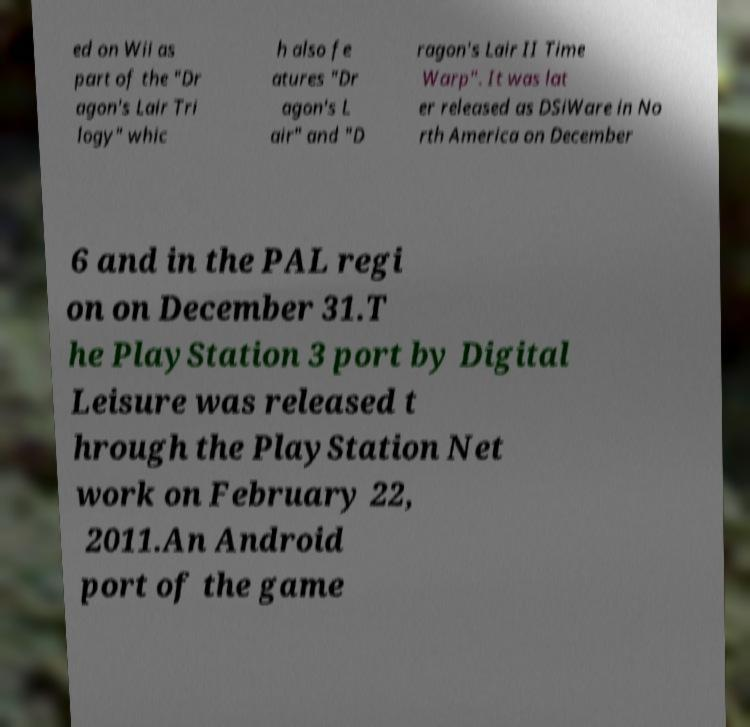What messages or text are displayed in this image? I need them in a readable, typed format. ed on Wii as part of the "Dr agon's Lair Tri logy" whic h also fe atures "Dr agon's L air" and "D ragon's Lair II Time Warp". It was lat er released as DSiWare in No rth America on December 6 and in the PAL regi on on December 31.T he PlayStation 3 port by Digital Leisure was released t hrough the PlayStation Net work on February 22, 2011.An Android port of the game 